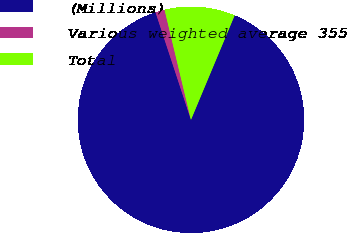Convert chart. <chart><loc_0><loc_0><loc_500><loc_500><pie_chart><fcel>(Millions)<fcel>Various weighted average 355<fcel>Total<nl><fcel>88.63%<fcel>1.32%<fcel>10.05%<nl></chart> 